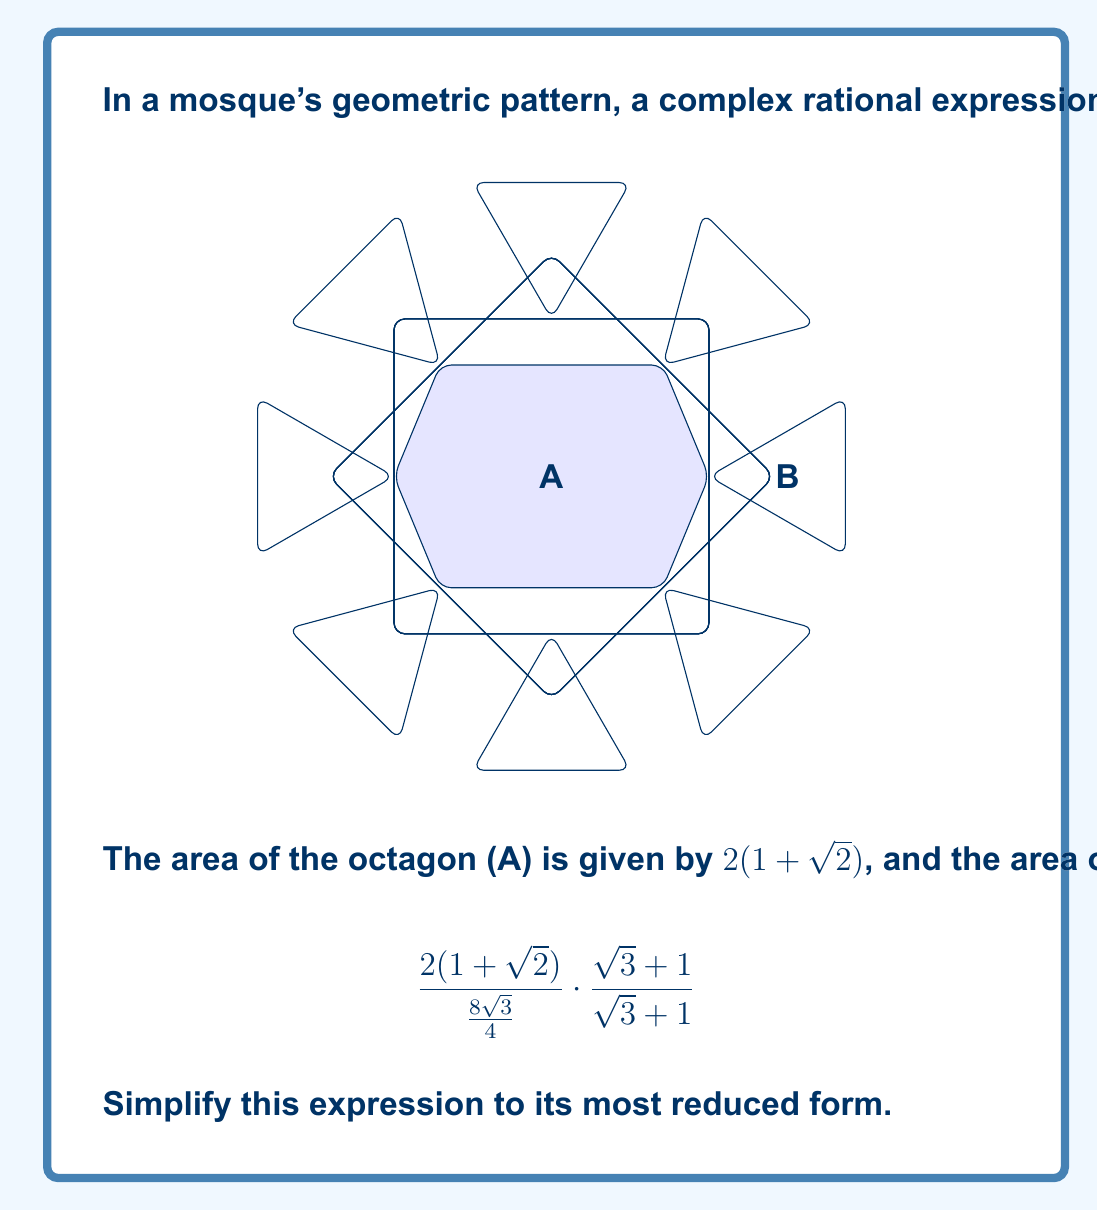Can you answer this question? Let's simplify this complex rational expression step by step:

1) First, let's simplify the denominator of the main fraction:
   $$\frac{8\sqrt{3}}{4} = 2\sqrt{3}$$

2) Now our expression looks like:
   $$\frac{2(1+\sqrt{2})}{2\sqrt{3}} \cdot \frac{\sqrt{3}+1}{\sqrt{3}+1}$$

3) Simplify the first fraction:
   $$\frac{1+\sqrt{2}}{\sqrt{3}} \cdot \frac{\sqrt{3}+1}{\sqrt{3}+1}$$

4) Multiply the numerators and denominators:
   $$\frac{(1+\sqrt{2})(\sqrt{3}+1)}{\sqrt{3}(\sqrt{3}+1)}$$

5) The $(\sqrt{3}+1)$ terms cancel out:
   $$\frac{1+\sqrt{2}}{\sqrt{3}}$$

6) To rationalize the denominator, multiply both numerator and denominator by $\sqrt{3}$:
   $$\frac{(1+\sqrt{2})\sqrt{3}}{\sqrt{3}\sqrt{3}} = \frac{(1+\sqrt{2})\sqrt{3}}{3}$$

7) Distribute $\sqrt{3}$ in the numerator:
   $$\frac{\sqrt{3}+\sqrt{6}}{3}$$

This is the most simplified form of the expression.
Answer: $$\frac{\sqrt{3}+\sqrt{6}}{3}$$ 